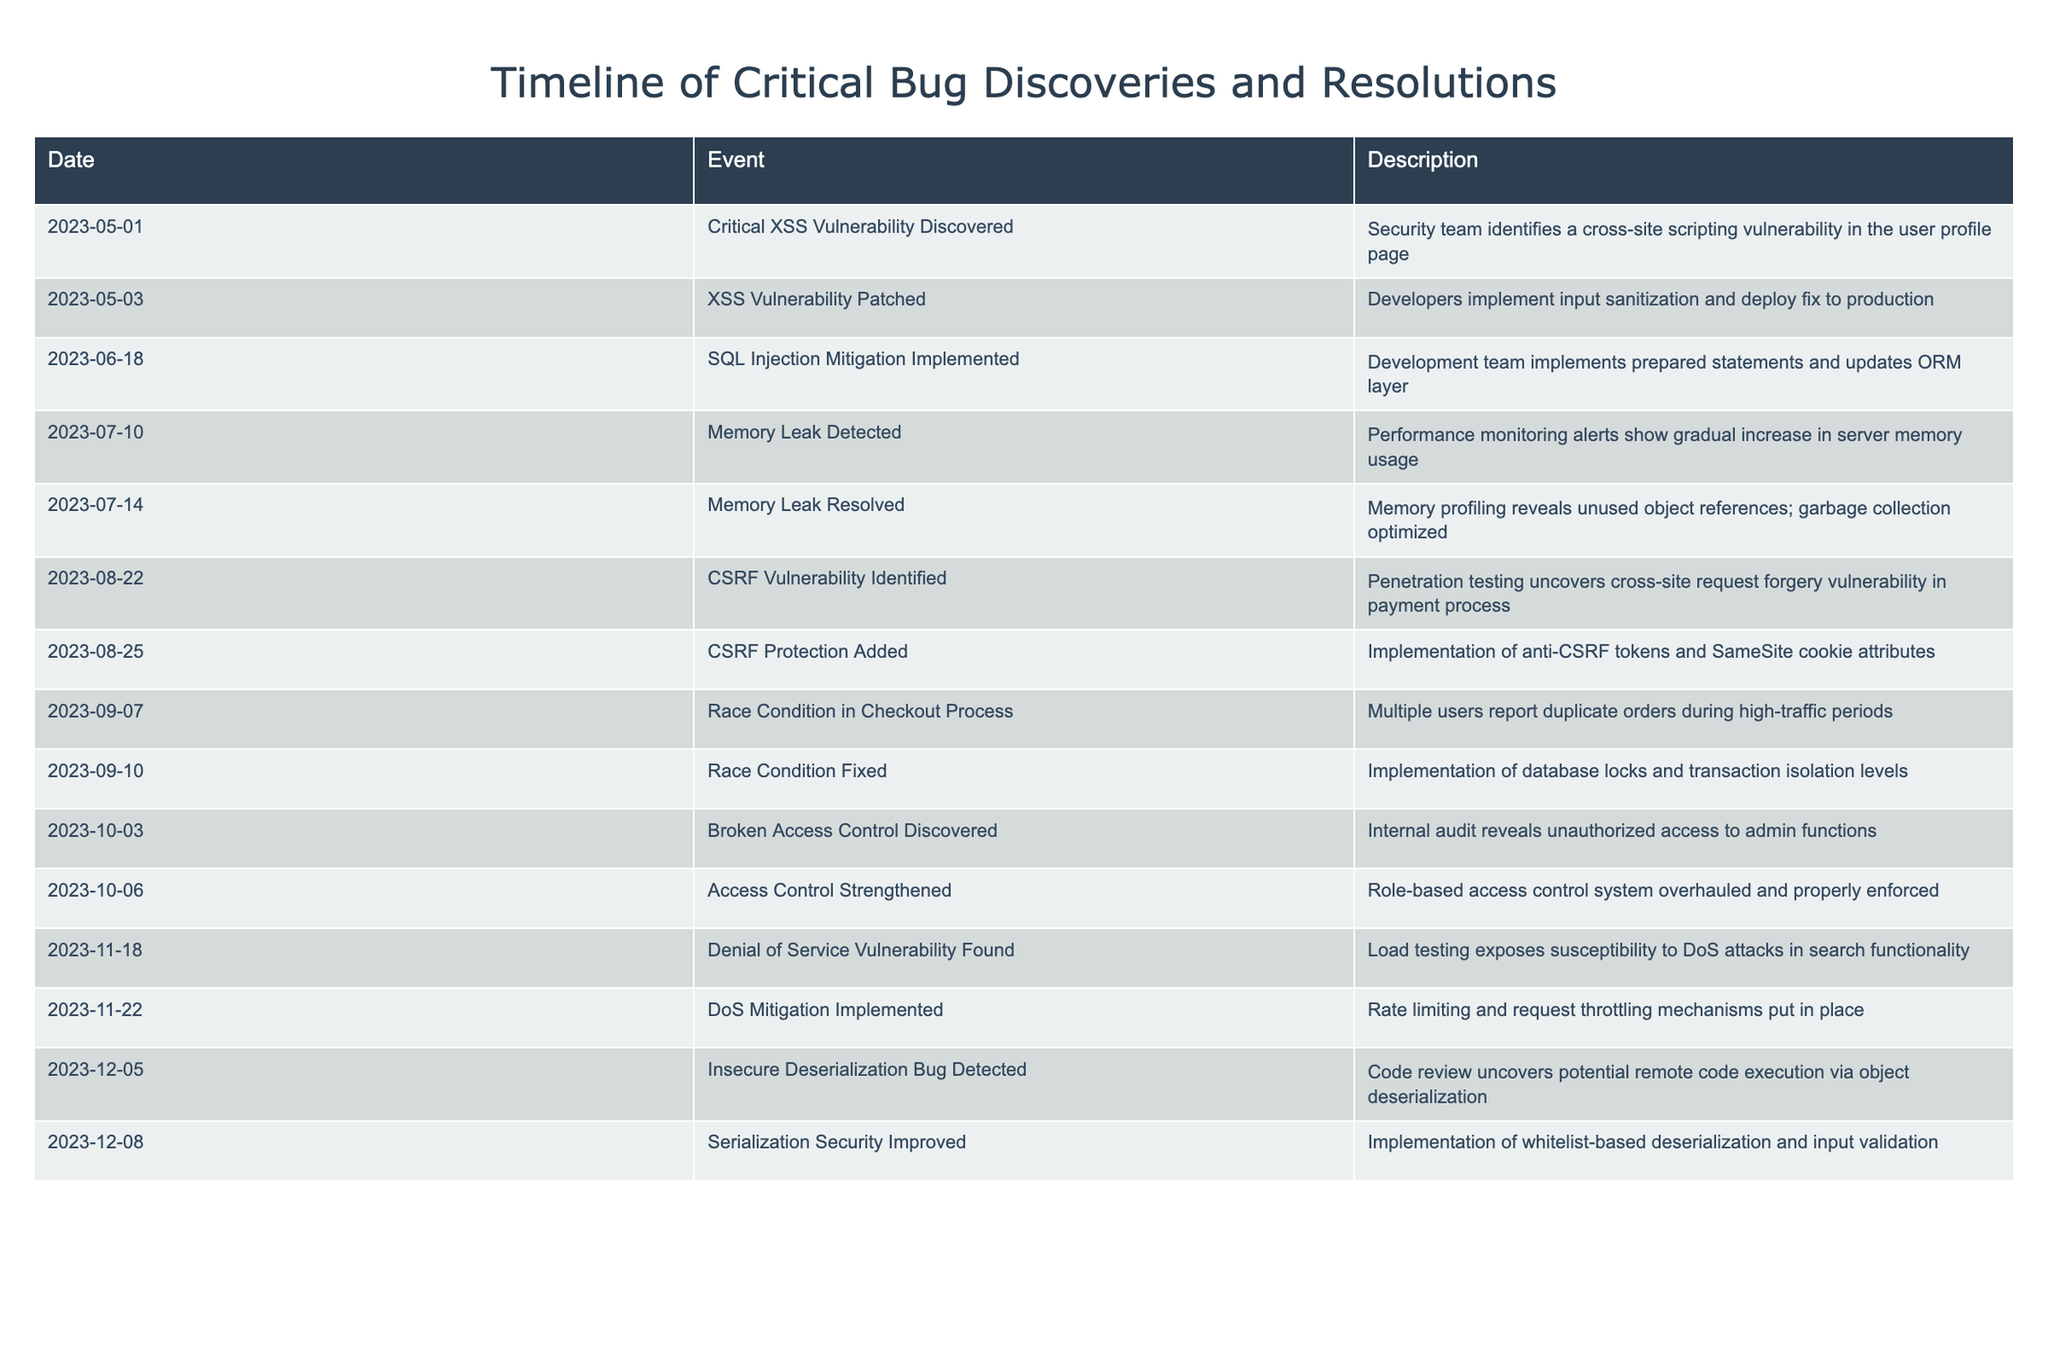What vulnerability was discovered on May 1, 2023? The table shows that on May 1, 2023, a critical XSS vulnerability was discovered in the user profile page.
Answer: Critical XSS vulnerability When was the CSRF vulnerability identified? According to the table, the CSRF vulnerability was identified on August 22, 2023.
Answer: August 22, 2023 Was the memory leak resolved before the CSRF vulnerability was identified? Looking at the timeline, the memory leak was resolved on July 14, 2023, which is before the CSRF vulnerability was identified on August 22, 2023. Thus, the statement is true.
Answer: Yes How many days elapsed between the discovery of the critical XSS vulnerability and its patch? The critical XSS vulnerability was discovered on May 1 and patched on May 3, which is a difference of 2 days.
Answer: 2 days What is the latest bug identified in the table? The table lists the latest bug detected as the Insecure Deserialization Bug on December 5, 2023.
Answer: Insecure Deserialization Bug How many bugs were patched between July 10 and October 6, 2023? Between these dates, there were three bugs that were patched: the memory leak on July 14, the race condition on September 10, and the access control on October 6. So, the total is three.
Answer: 3 bugs Which vulnerability was addressed with the implementation of anti-CSRF tokens? The implementation of anti-CSRF tokens relates to the CSRF vulnerability identified on August 22, which was then protected on August 25, 2023.
Answer: CSRF vulnerability What was the improvement made after discovering the Denial of Service vulnerability? After discovering the Denial of Service vulnerability on November 18, rate limiting and request throttling mechanisms were implemented on November 22, 2023.
Answer: Rate limiting and request throttling 